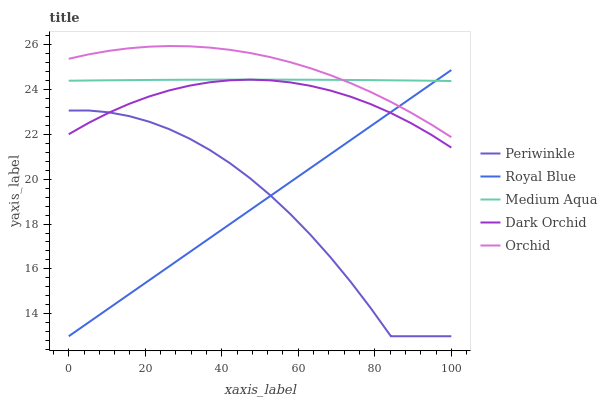Does Periwinkle have the minimum area under the curve?
Answer yes or no. Yes. Does Orchid have the maximum area under the curve?
Answer yes or no. Yes. Does Royal Blue have the minimum area under the curve?
Answer yes or no. No. Does Royal Blue have the maximum area under the curve?
Answer yes or no. No. Is Royal Blue the smoothest?
Answer yes or no. Yes. Is Periwinkle the roughest?
Answer yes or no. Yes. Is Periwinkle the smoothest?
Answer yes or no. No. Is Royal Blue the roughest?
Answer yes or no. No. Does Royal Blue have the lowest value?
Answer yes or no. Yes. Does Dark Orchid have the lowest value?
Answer yes or no. No. Does Orchid have the highest value?
Answer yes or no. Yes. Does Royal Blue have the highest value?
Answer yes or no. No. Is Periwinkle less than Orchid?
Answer yes or no. Yes. Is Medium Aqua greater than Periwinkle?
Answer yes or no. Yes. Does Royal Blue intersect Dark Orchid?
Answer yes or no. Yes. Is Royal Blue less than Dark Orchid?
Answer yes or no. No. Is Royal Blue greater than Dark Orchid?
Answer yes or no. No. Does Periwinkle intersect Orchid?
Answer yes or no. No. 